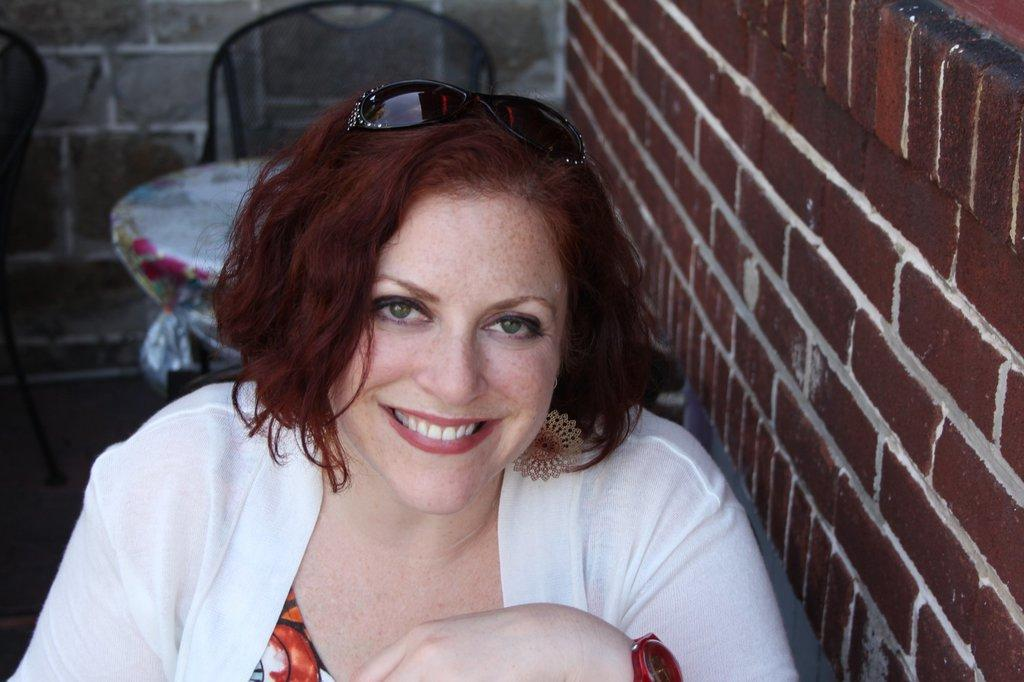Who is present in the image? There is a woman in the image. What is the woman wearing? The woman is wearing glasses. What is the woman's facial expression? The woman is smiling. What type of furniture can be seen in the image? There are chairs and a table in the image. How is the table decorated? The table is covered with a cloth. What type of structure is visible in the image? There are walls visible in the image. How does the woman fold the pot in the image? There is no pot present in the image, and therefore no folding can be observed. 